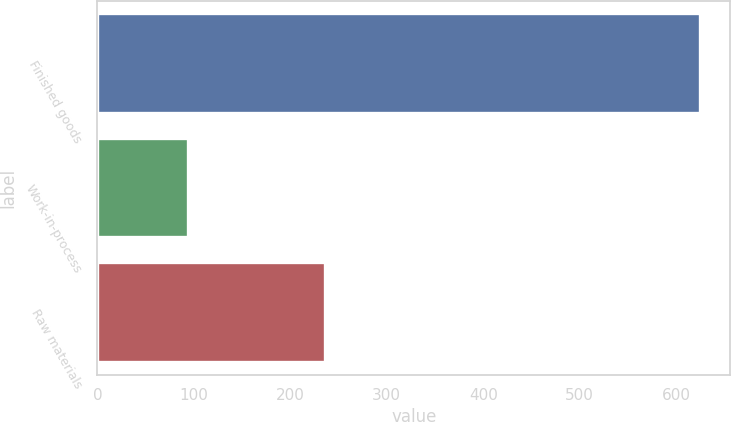<chart> <loc_0><loc_0><loc_500><loc_500><bar_chart><fcel>Finished goods<fcel>Work-in-process<fcel>Raw materials<nl><fcel>625<fcel>94<fcel>236<nl></chart> 